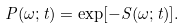Convert formula to latex. <formula><loc_0><loc_0><loc_500><loc_500>P ( \omega ; t ) = \exp [ - S ( \omega ; t ) ] .</formula> 